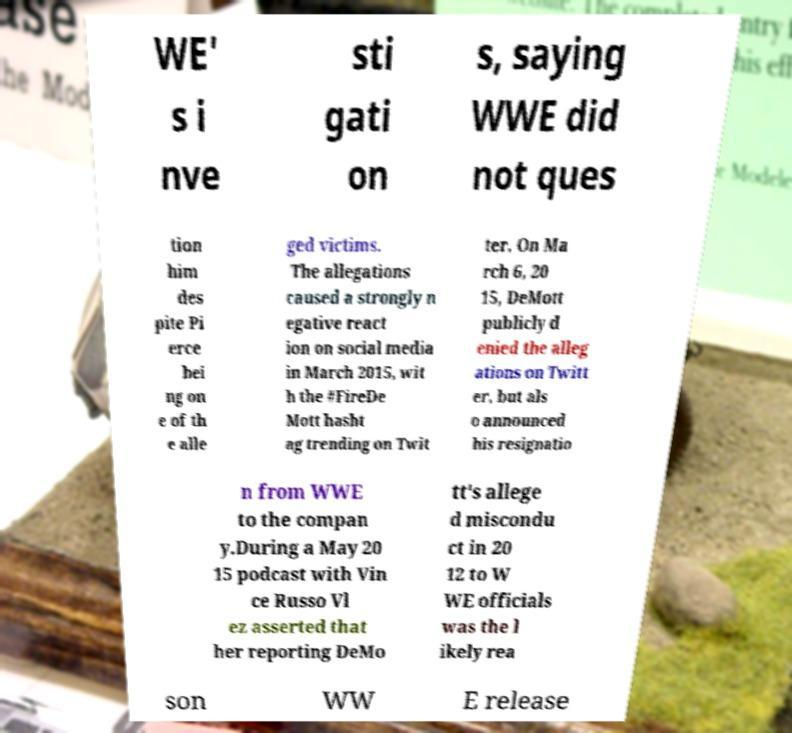Could you assist in decoding the text presented in this image and type it out clearly? WE' s i nve sti gati on s, saying WWE did not ques tion him des pite Pi erce bei ng on e of th e alle ged victims. The allegations caused a strongly n egative react ion on social media in March 2015, wit h the #FireDe Mott hasht ag trending on Twit ter. On Ma rch 6, 20 15, DeMott publicly d enied the alleg ations on Twitt er, but als o announced his resignatio n from WWE to the compan y.During a May 20 15 podcast with Vin ce Russo Vl ez asserted that her reporting DeMo tt's allege d miscondu ct in 20 12 to W WE officials was the l ikely rea son WW E release 